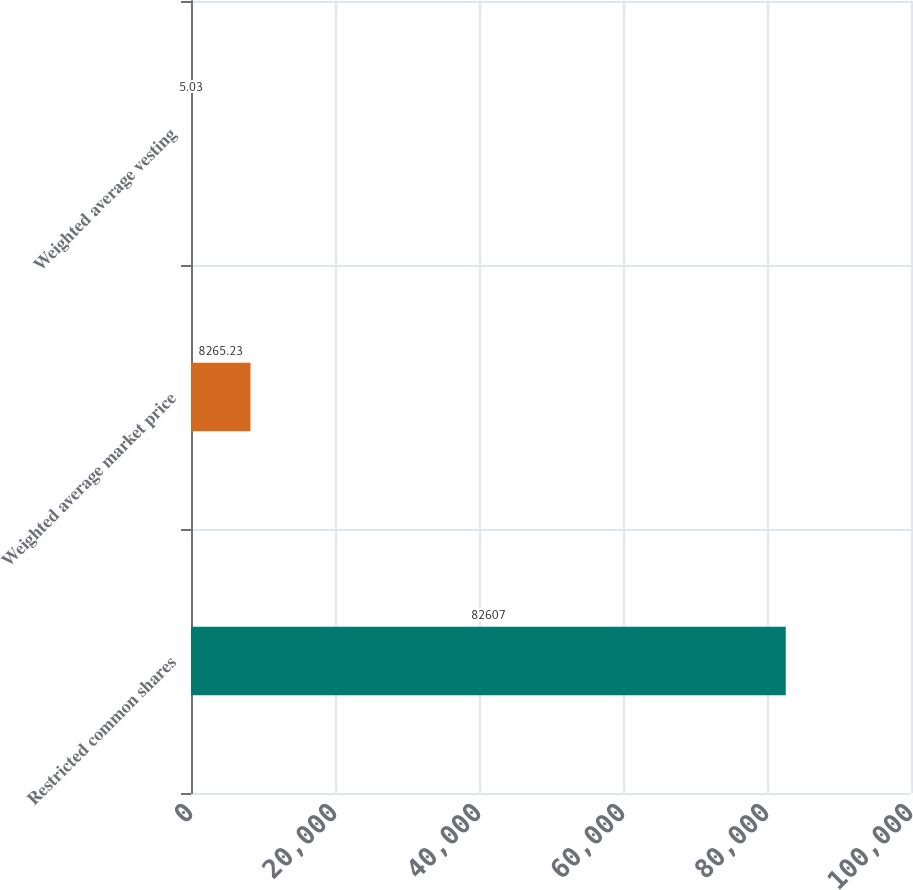Convert chart to OTSL. <chart><loc_0><loc_0><loc_500><loc_500><bar_chart><fcel>Restricted common shares<fcel>Weighted average market price<fcel>Weighted average vesting<nl><fcel>82607<fcel>8265.23<fcel>5.03<nl></chart> 